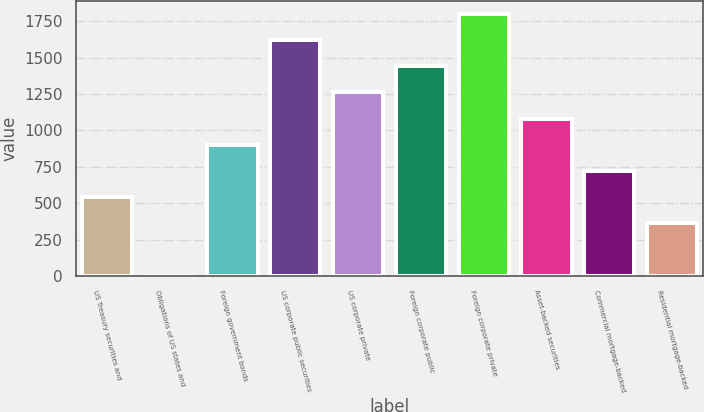Convert chart. <chart><loc_0><loc_0><loc_500><loc_500><bar_chart><fcel>US Treasury securities and<fcel>Obligations of US states and<fcel>Foreign government bonds<fcel>US corporate public securities<fcel>US corporate private<fcel>Foreign corporate public<fcel>Foreign corporate private<fcel>Asset-backed securities<fcel>Commercial mortgage-backed<fcel>Residential mortgage-backed<nl><fcel>541.3<fcel>1<fcel>901.5<fcel>1621.9<fcel>1261.7<fcel>1441.8<fcel>1802<fcel>1081.6<fcel>721.4<fcel>361.2<nl></chart> 